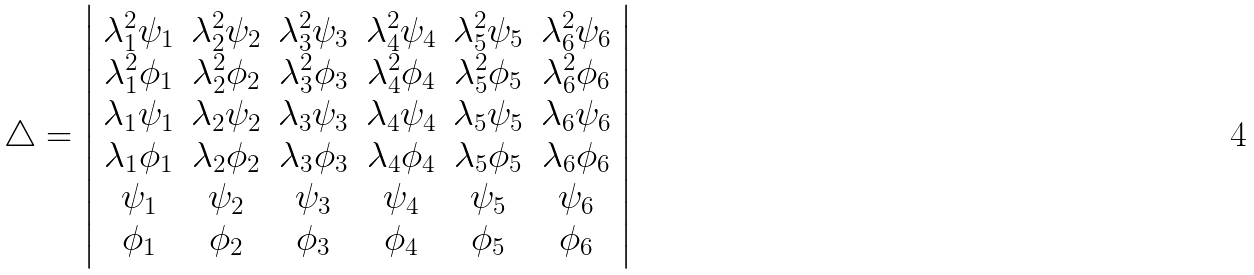Convert formula to latex. <formula><loc_0><loc_0><loc_500><loc_500>\triangle = \left | \begin{array} { c c c c c c } \lambda _ { 1 } ^ { 2 } \psi _ { 1 } & \lambda _ { 2 } ^ { 2 } \psi _ { 2 } & \lambda _ { 3 } ^ { 2 } \psi _ { 3 } & \lambda _ { 4 } ^ { 2 } \psi _ { 4 } & \lambda _ { 5 } ^ { 2 } \psi _ { 5 } & \lambda _ { 6 } ^ { 2 } \psi _ { 6 } \\ \lambda _ { 1 } ^ { 2 } \phi _ { 1 } & \lambda _ { 2 } ^ { 2 } \phi _ { 2 } & \lambda _ { 3 } ^ { 2 } \phi _ { 3 } & \lambda _ { 4 } ^ { 2 } \phi _ { 4 } & \lambda _ { 5 } ^ { 2 } \phi _ { 5 } & \lambda _ { 6 } ^ { 2 } \phi _ { 6 } \\ \lambda _ { 1 } \psi _ { 1 } & \lambda _ { 2 } \psi _ { 2 } & \lambda _ { 3 } \psi _ { 3 } & \lambda _ { 4 } \psi _ { 4 } & \lambda _ { 5 } \psi _ { 5 } & \lambda _ { 6 } \psi _ { 6 } \\ \lambda _ { 1 } \phi _ { 1 } & \lambda _ { 2 } \phi _ { 2 } & \lambda _ { 3 } \phi _ { 3 } & \lambda _ { 4 } \phi _ { 4 } & \lambda _ { 5 } \phi _ { 5 } & \lambda _ { 6 } \phi _ { 6 } \\ \psi _ { 1 } & \psi _ { 2 } & \psi _ { 3 } & \psi _ { 4 } & \psi _ { 5 } & \psi _ { 6 } \\ \phi _ { 1 } & \phi _ { 2 } & \phi _ { 3 } & \phi _ { 4 } & \phi _ { 5 } & \phi _ { 6 } \end{array} \right |</formula> 